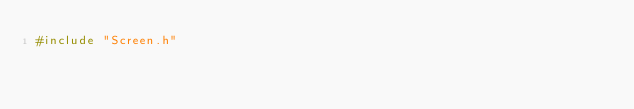<code> <loc_0><loc_0><loc_500><loc_500><_C++_>#include "Screen.h"


</code> 